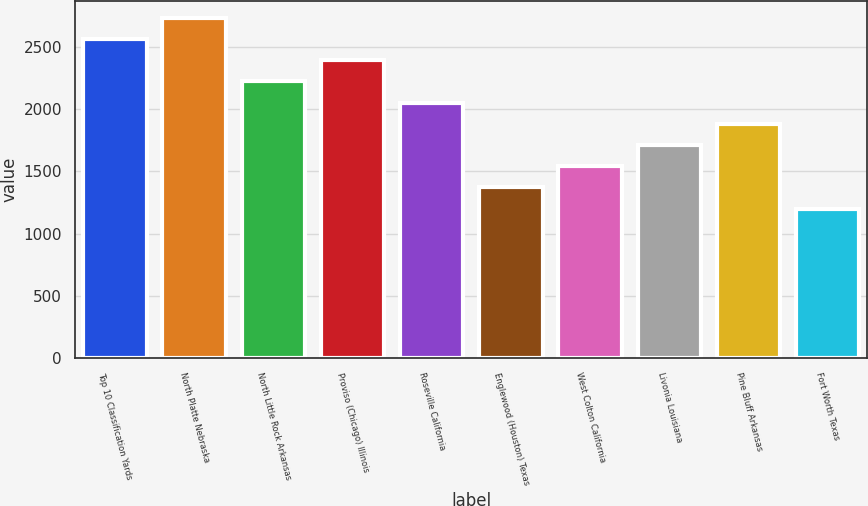Convert chart to OTSL. <chart><loc_0><loc_0><loc_500><loc_500><bar_chart><fcel>Top 10 Classification Yards<fcel>North Platte Nebraska<fcel>North Little Rock Arkansas<fcel>Proviso (Chicago) Illinois<fcel>Roseville California<fcel>Englewood (Houston) Texas<fcel>West Colton California<fcel>Livonia Louisiana<fcel>Pine Bluff Arkansas<fcel>Fort Worth Texas<nl><fcel>2560<fcel>2730<fcel>2220<fcel>2390<fcel>2050<fcel>1370<fcel>1540<fcel>1710<fcel>1880<fcel>1200<nl></chart> 